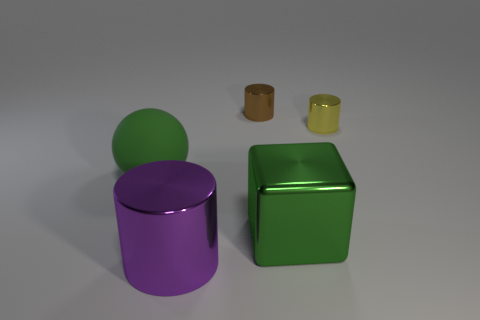Subtract all large cylinders. How many cylinders are left? 2 Subtract 1 cylinders. How many cylinders are left? 2 Add 3 tiny yellow cylinders. How many objects exist? 8 Subtract all blocks. How many objects are left? 4 Subtract 1 green cubes. How many objects are left? 4 Subtract all spheres. Subtract all brown things. How many objects are left? 3 Add 2 brown metallic things. How many brown metallic things are left? 3 Add 2 green blocks. How many green blocks exist? 3 